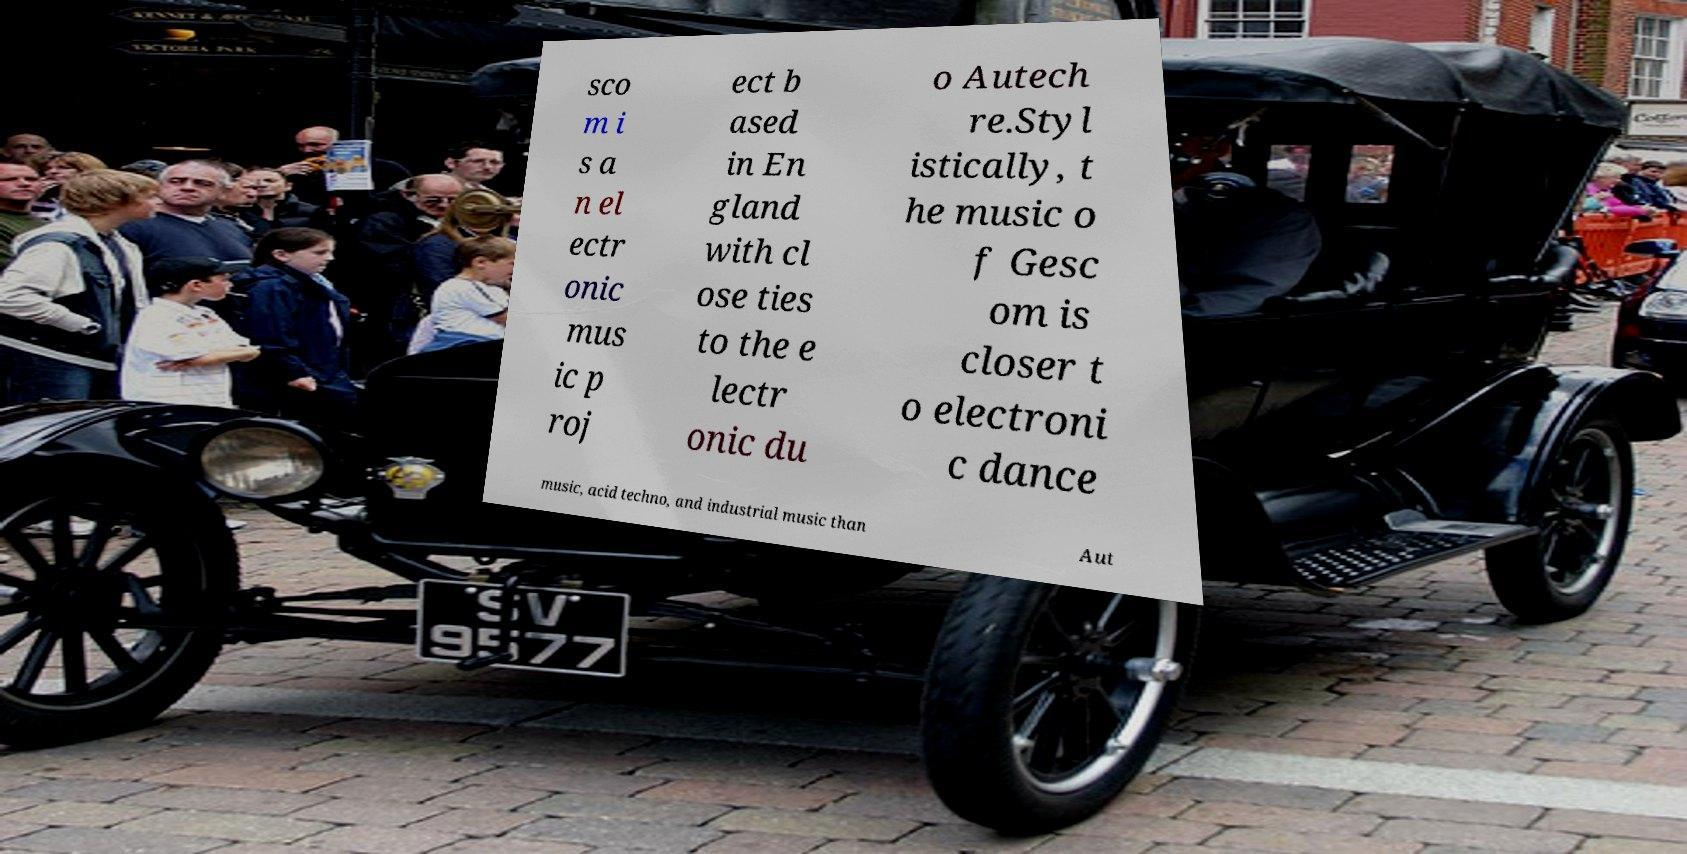For documentation purposes, I need the text within this image transcribed. Could you provide that? sco m i s a n el ectr onic mus ic p roj ect b ased in En gland with cl ose ties to the e lectr onic du o Autech re.Styl istically, t he music o f Gesc om is closer t o electroni c dance music, acid techno, and industrial music than Aut 